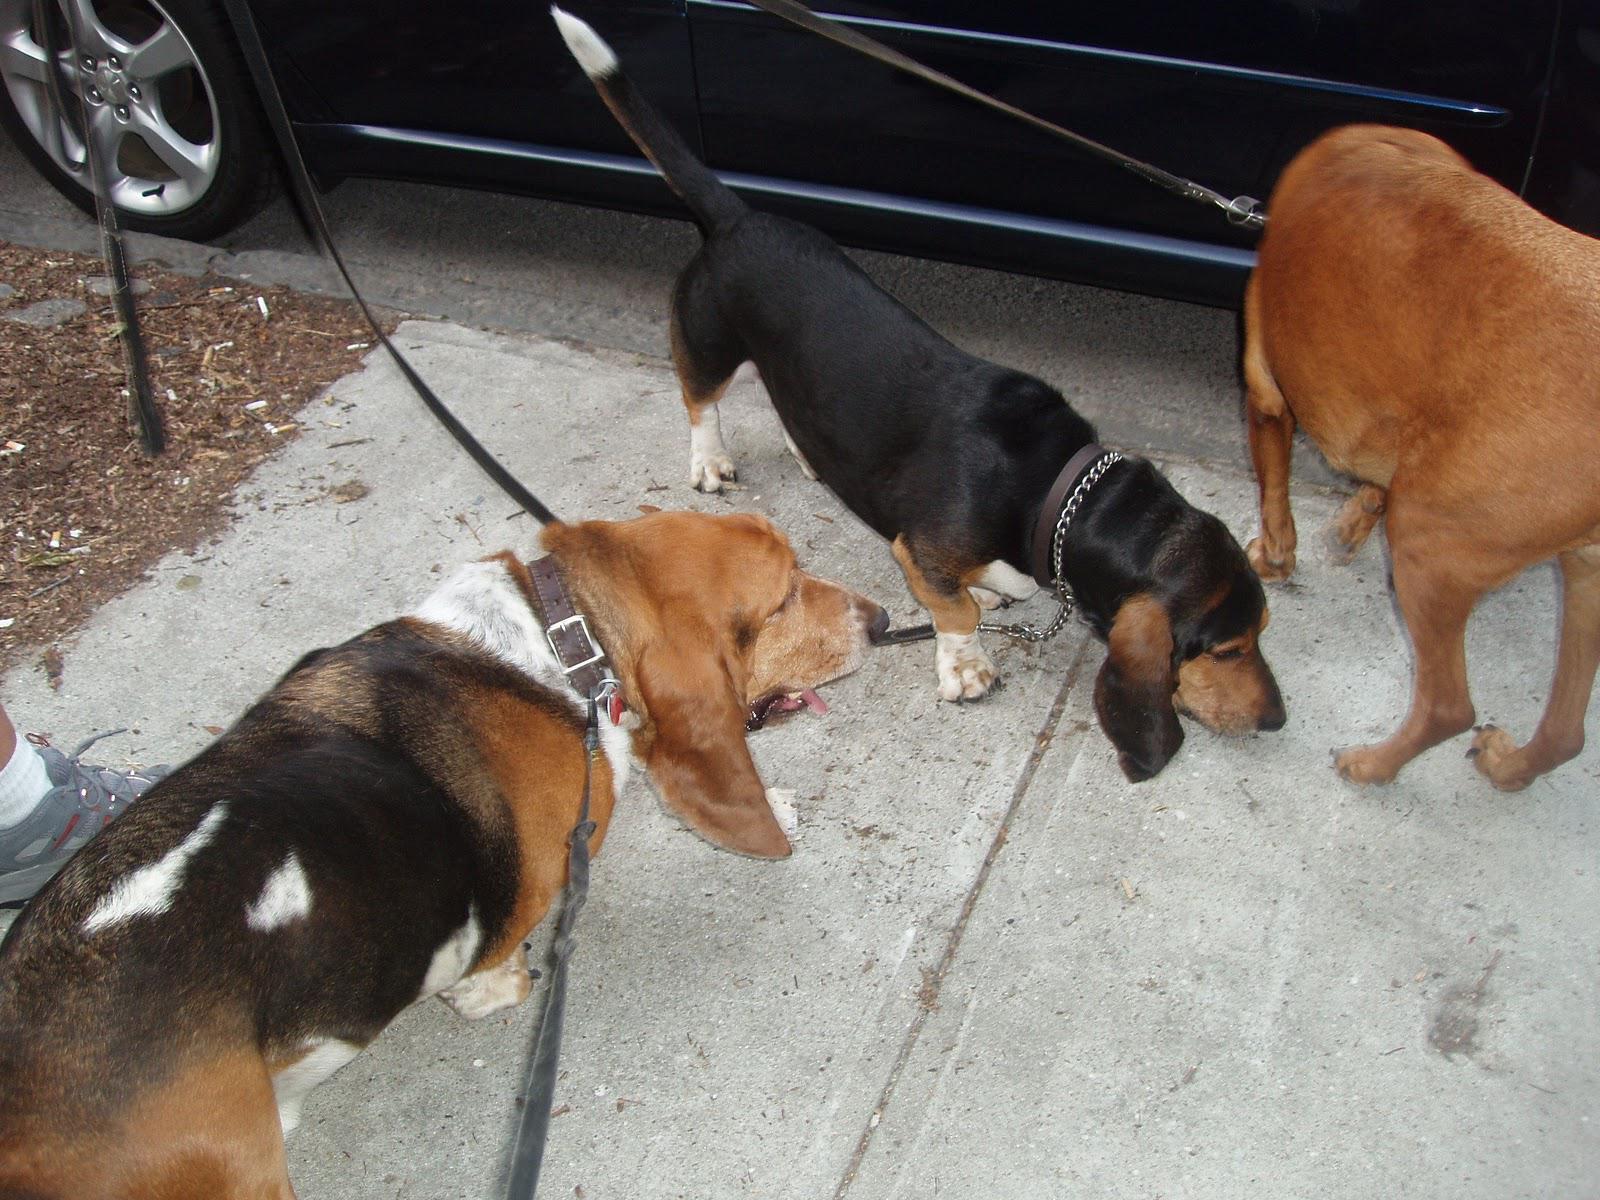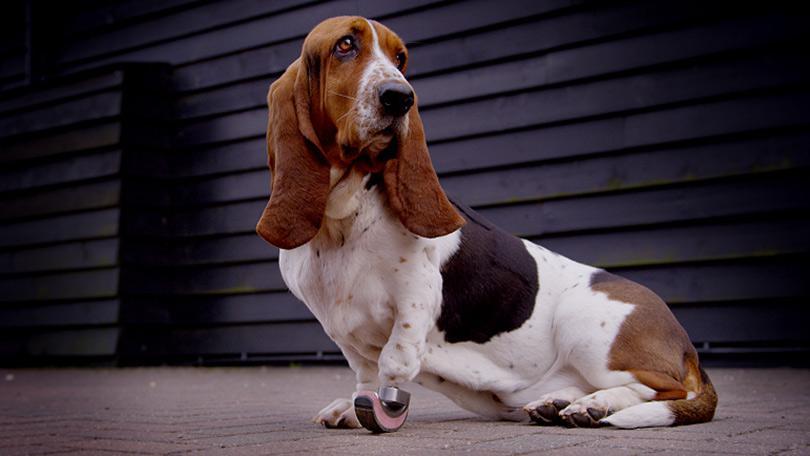The first image is the image on the left, the second image is the image on the right. Evaluate the accuracy of this statement regarding the images: "The dog in the left image is looking towards the camera.". Is it true? Answer yes or no. No. The first image is the image on the left, the second image is the image on the right. Considering the images on both sides, is "An image shows a basset hound wearing a front foot prosthetic." valid? Answer yes or no. Yes. 